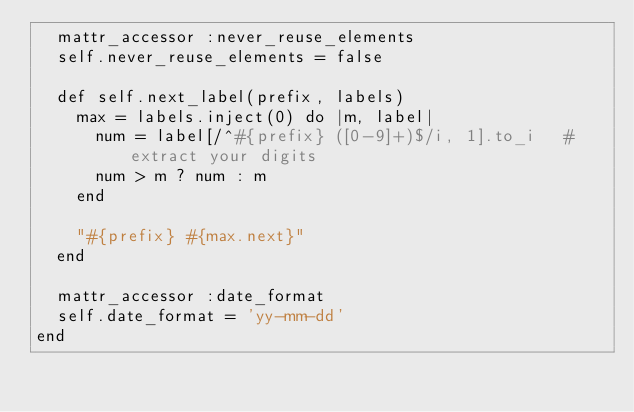Convert code to text. <code><loc_0><loc_0><loc_500><loc_500><_Ruby_>  mattr_accessor :never_reuse_elements
  self.never_reuse_elements = false

  def self.next_label(prefix, labels)
    max = labels.inject(0) do |m, label|
      num = label[/^#{prefix} ([0-9]+)$/i, 1].to_i   # extract your digits
      num > m ? num : m
    end

    "#{prefix} #{max.next}"
  end

  mattr_accessor :date_format
  self.date_format = 'yy-mm-dd'
end
</code> 